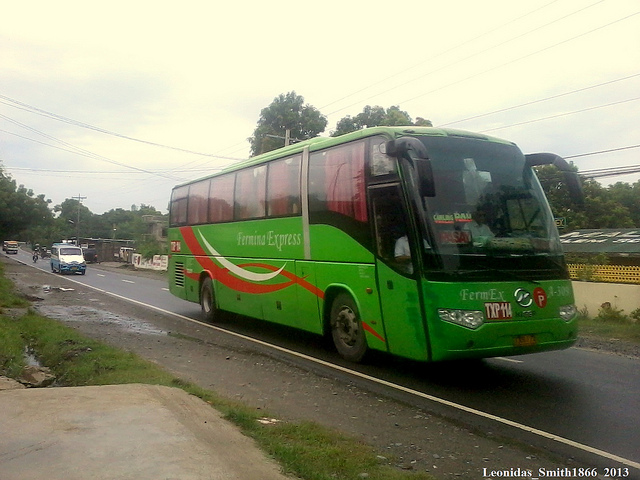Please extract the text content from this image. Smith1866 Fermina TXP Ex 2013 Leonidas P 6 Express 